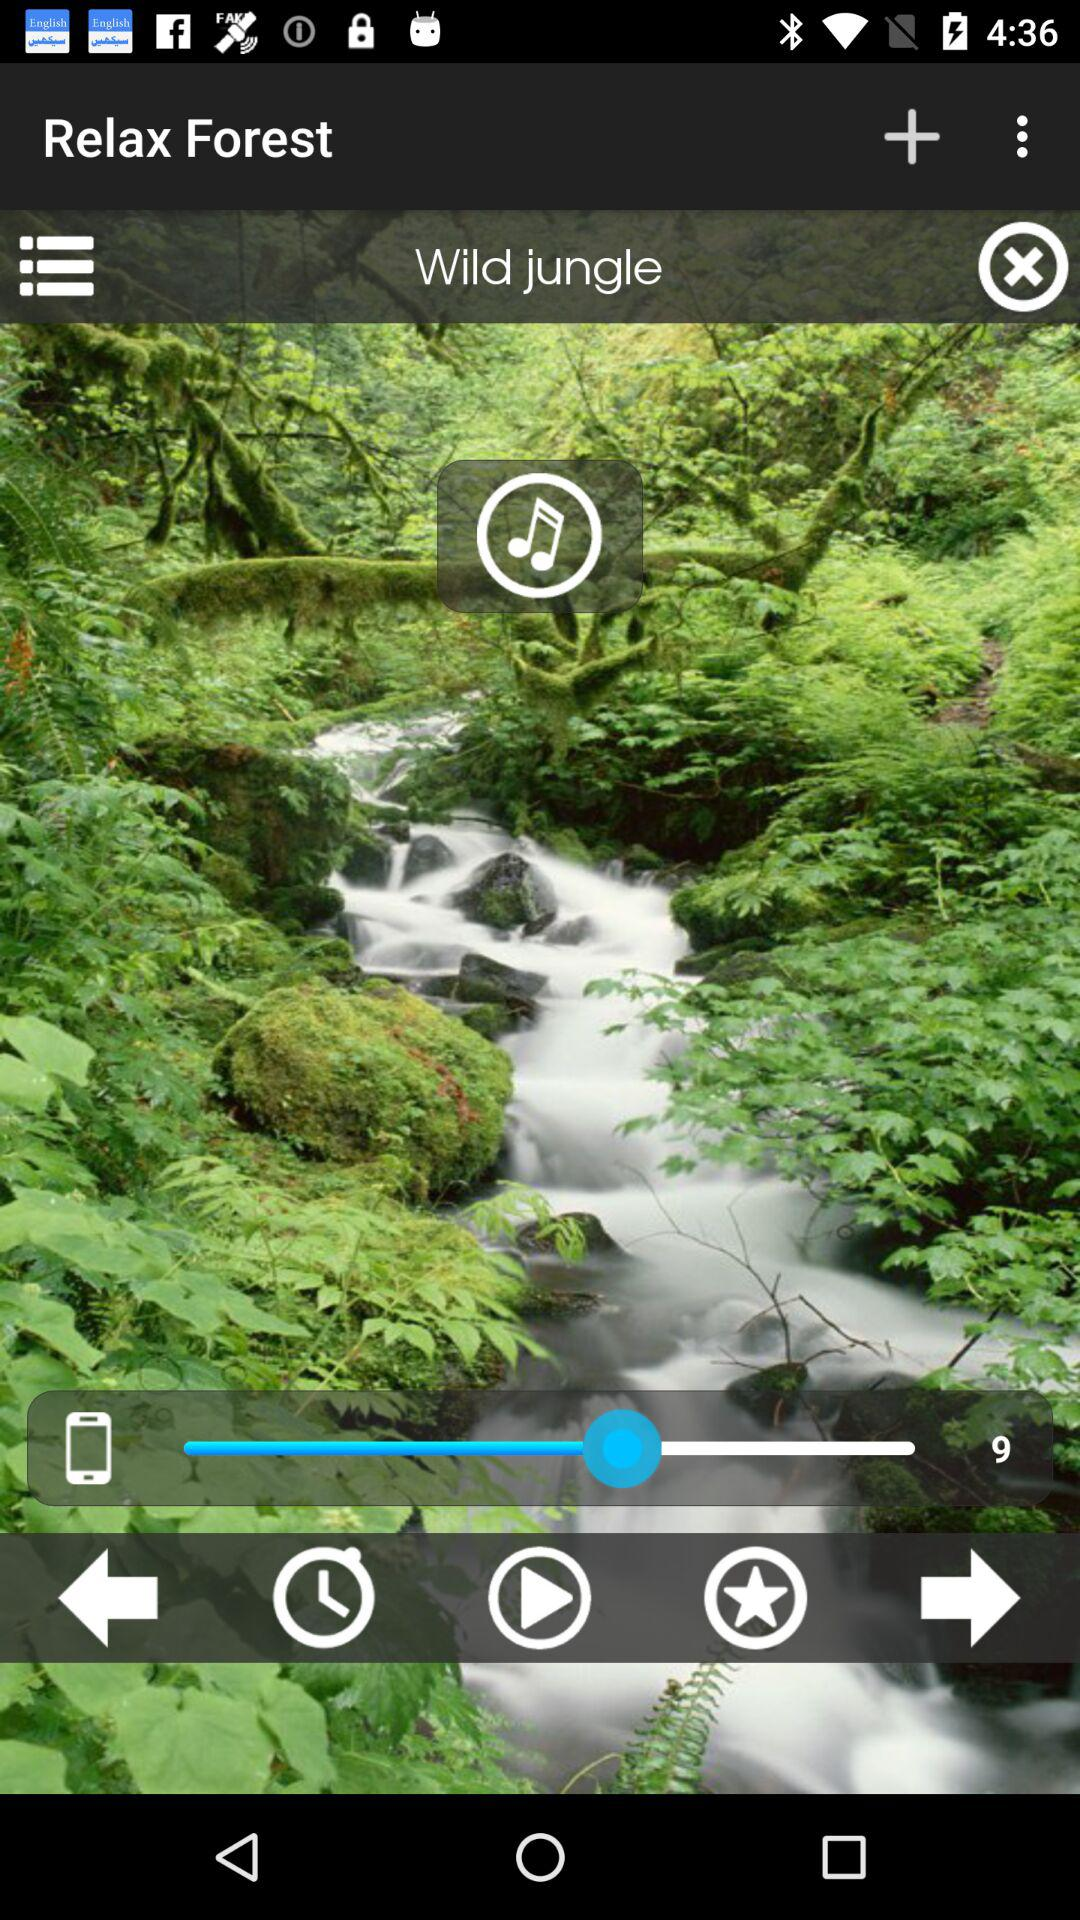What is the set level of sound? The set level of sound is 9. 